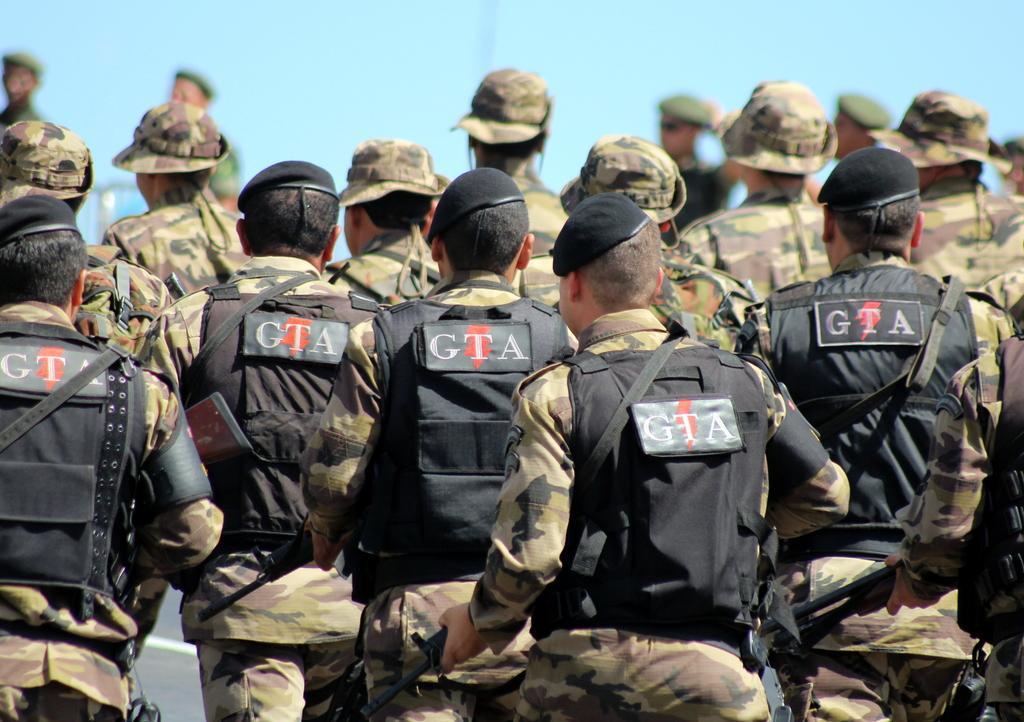Can you describe this image briefly? In this image I can see number of persons are wearing uniforms which are brown and black in color are standing, wearing caps and holding weapons. In the background I can see the sky. 